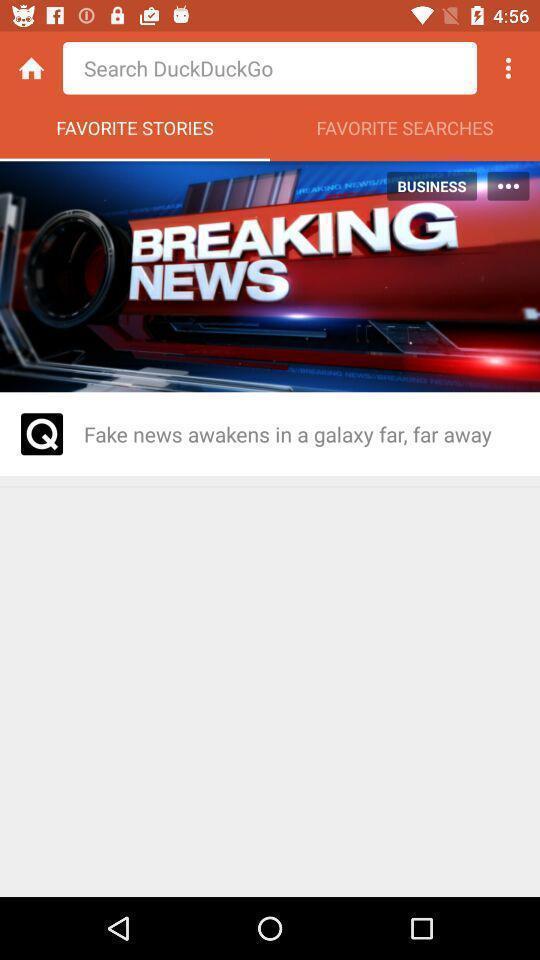Tell me what you see in this picture. Search page for the browsing application. 